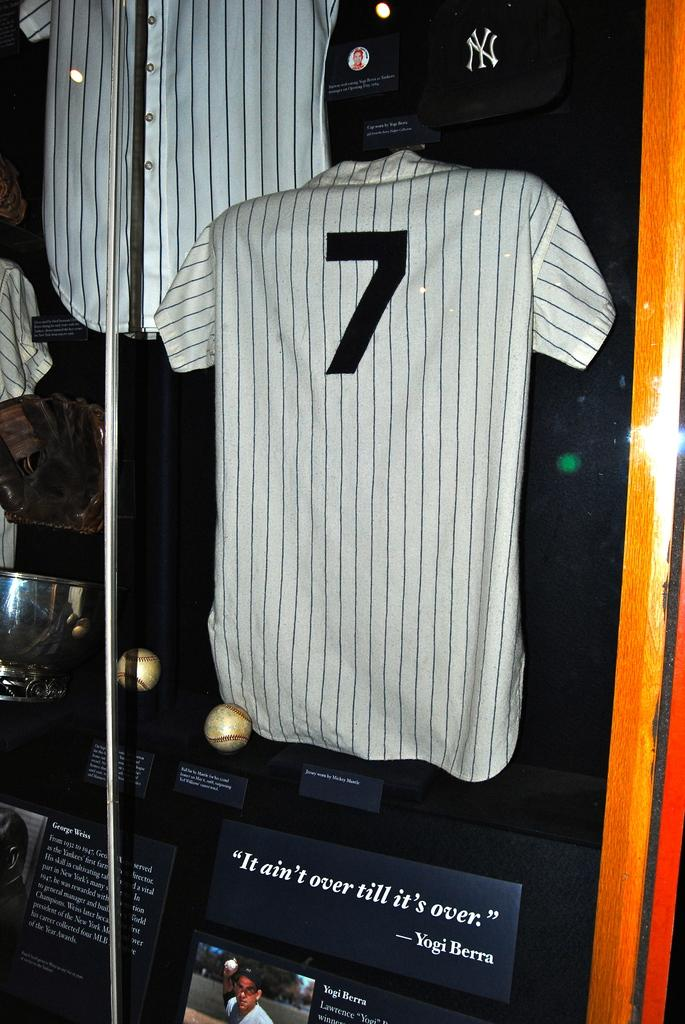<image>
Create a compact narrative representing the image presented. A New York Yankees jersey number seven with a quote from Yogi Berra under it. 